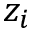<formula> <loc_0><loc_0><loc_500><loc_500>z _ { i }</formula> 